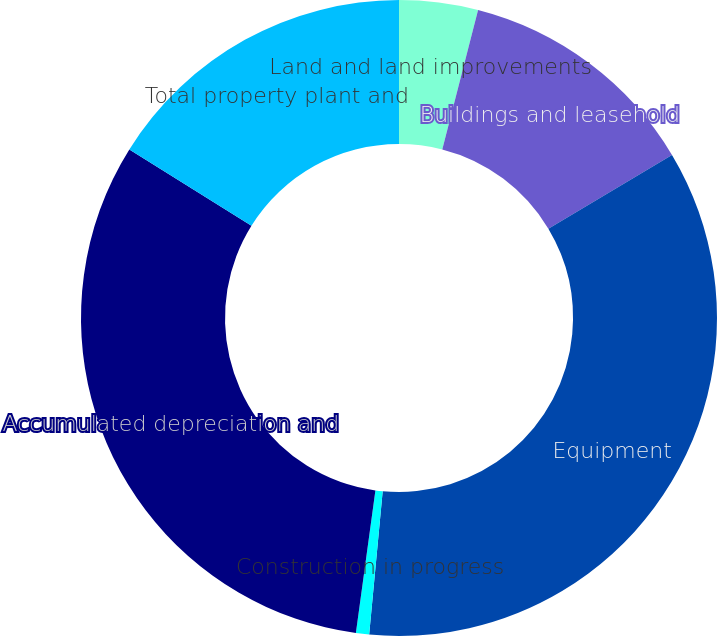<chart> <loc_0><loc_0><loc_500><loc_500><pie_chart><fcel>Land and land improvements<fcel>Buildings and leasehold<fcel>Equipment<fcel>Construction in progress<fcel>Accumulated depreciation and<fcel>Total property plant and<nl><fcel>4.0%<fcel>12.43%<fcel>35.07%<fcel>0.67%<fcel>31.73%<fcel>16.11%<nl></chart> 